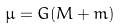<formula> <loc_0><loc_0><loc_500><loc_500>\mu = G ( M + m )</formula> 